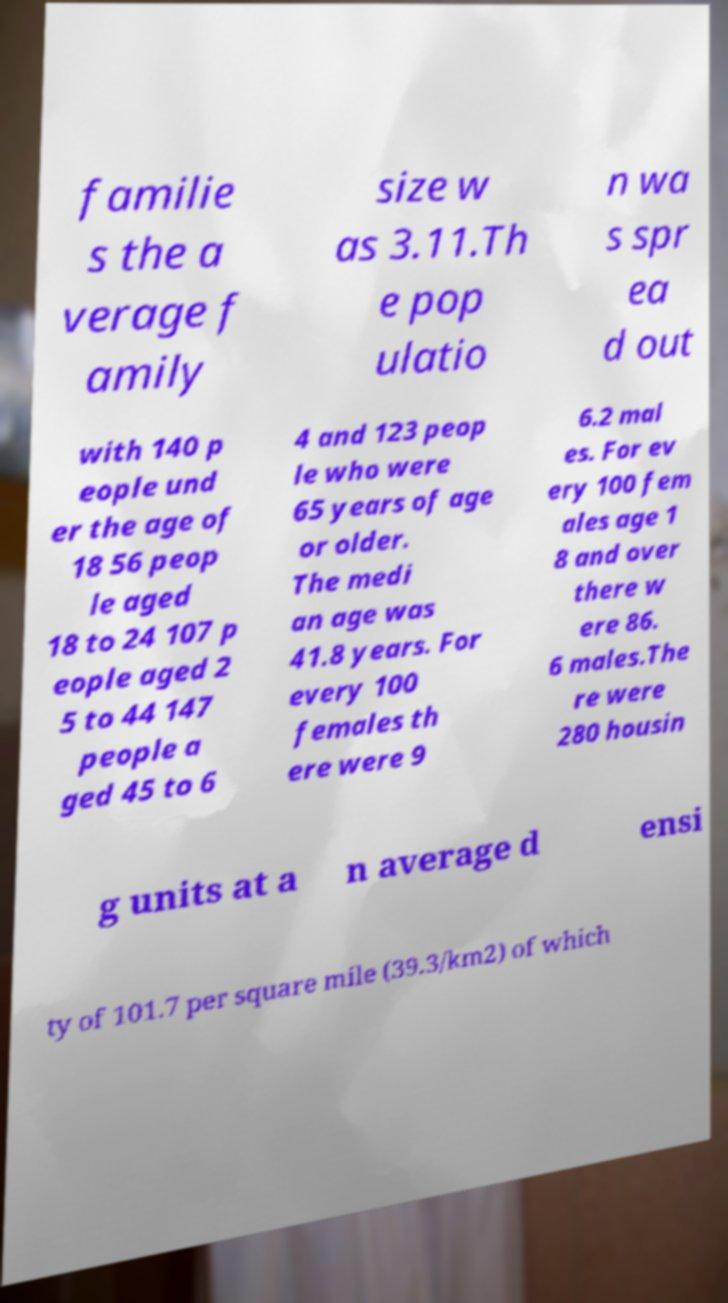I need the written content from this picture converted into text. Can you do that? familie s the a verage f amily size w as 3.11.Th e pop ulatio n wa s spr ea d out with 140 p eople und er the age of 18 56 peop le aged 18 to 24 107 p eople aged 2 5 to 44 147 people a ged 45 to 6 4 and 123 peop le who were 65 years of age or older. The medi an age was 41.8 years. For every 100 females th ere were 9 6.2 mal es. For ev ery 100 fem ales age 1 8 and over there w ere 86. 6 males.The re were 280 housin g units at a n average d ensi ty of 101.7 per square mile (39.3/km2) of which 